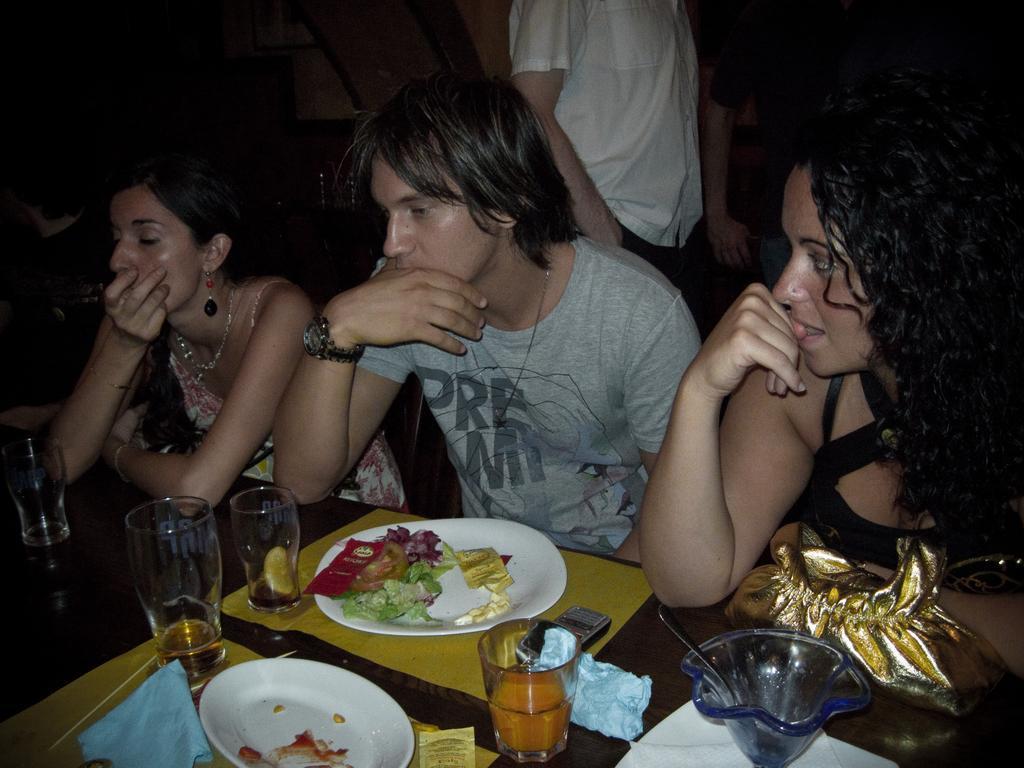Could you give a brief overview of what you see in this image? In this picture we can see three persons are sitting in front of a table, there are plates, glasses of drinks, a bag, a mobile phone, chopsticks and a cloth present on the table, in the background we can see another person is standing, there is a dark background. 